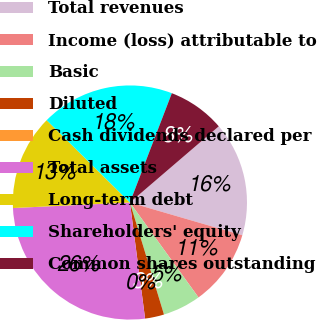Convert chart to OTSL. <chart><loc_0><loc_0><loc_500><loc_500><pie_chart><fcel>Total revenues<fcel>Income (loss) attributable to<fcel>Basic<fcel>Diluted<fcel>Cash dividends declared per<fcel>Total assets<fcel>Long-term debt<fcel>Shareholders' equity<fcel>Common shares outstanding<nl><fcel>15.79%<fcel>10.53%<fcel>5.26%<fcel>2.63%<fcel>0.0%<fcel>26.32%<fcel>13.16%<fcel>18.42%<fcel>7.89%<nl></chart> 